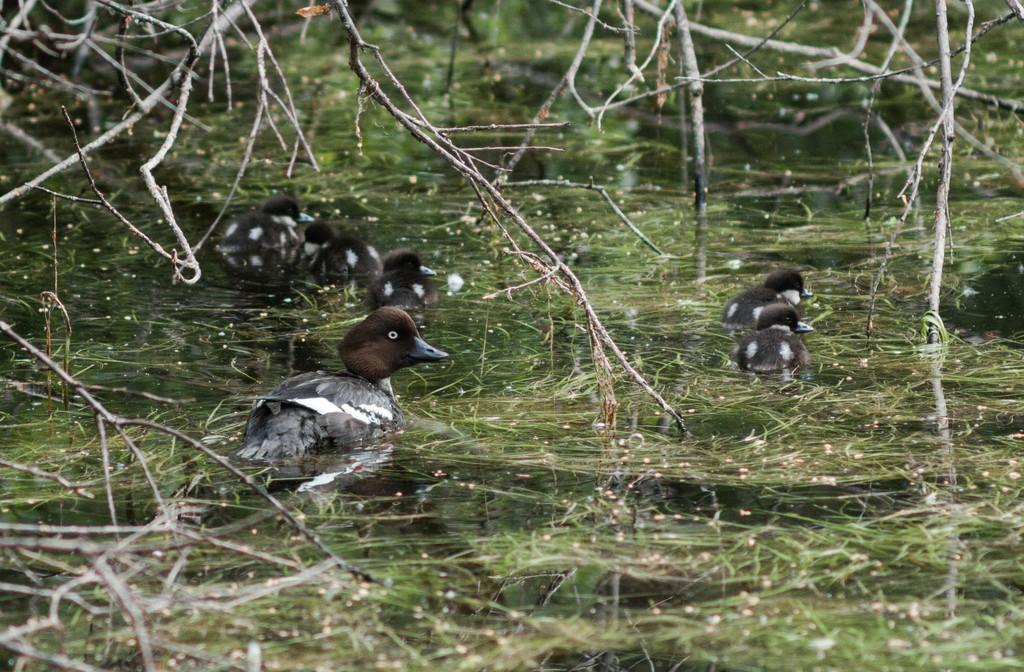Describe this image in one or two sentences. Here we can see water, birds and dried branches. 